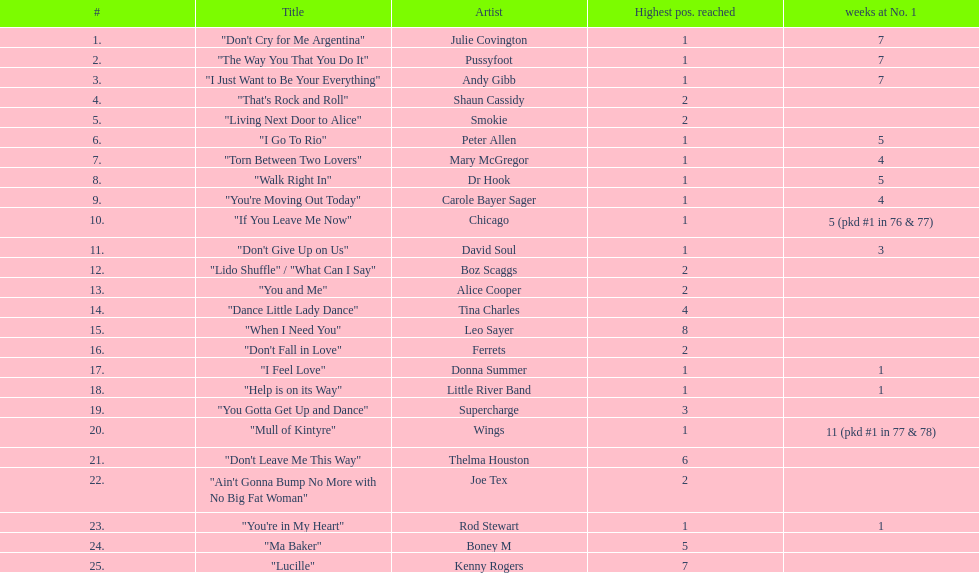Which song stayed at no.1 for the most amount of weeks. "Mull of Kintyre". 